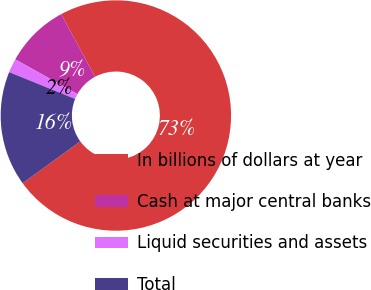<chart> <loc_0><loc_0><loc_500><loc_500><pie_chart><fcel>In billions of dollars at year<fcel>Cash at major central banks<fcel>Liquid securities and assets<fcel>Total<nl><fcel>72.87%<fcel>9.04%<fcel>1.95%<fcel>16.14%<nl></chart> 